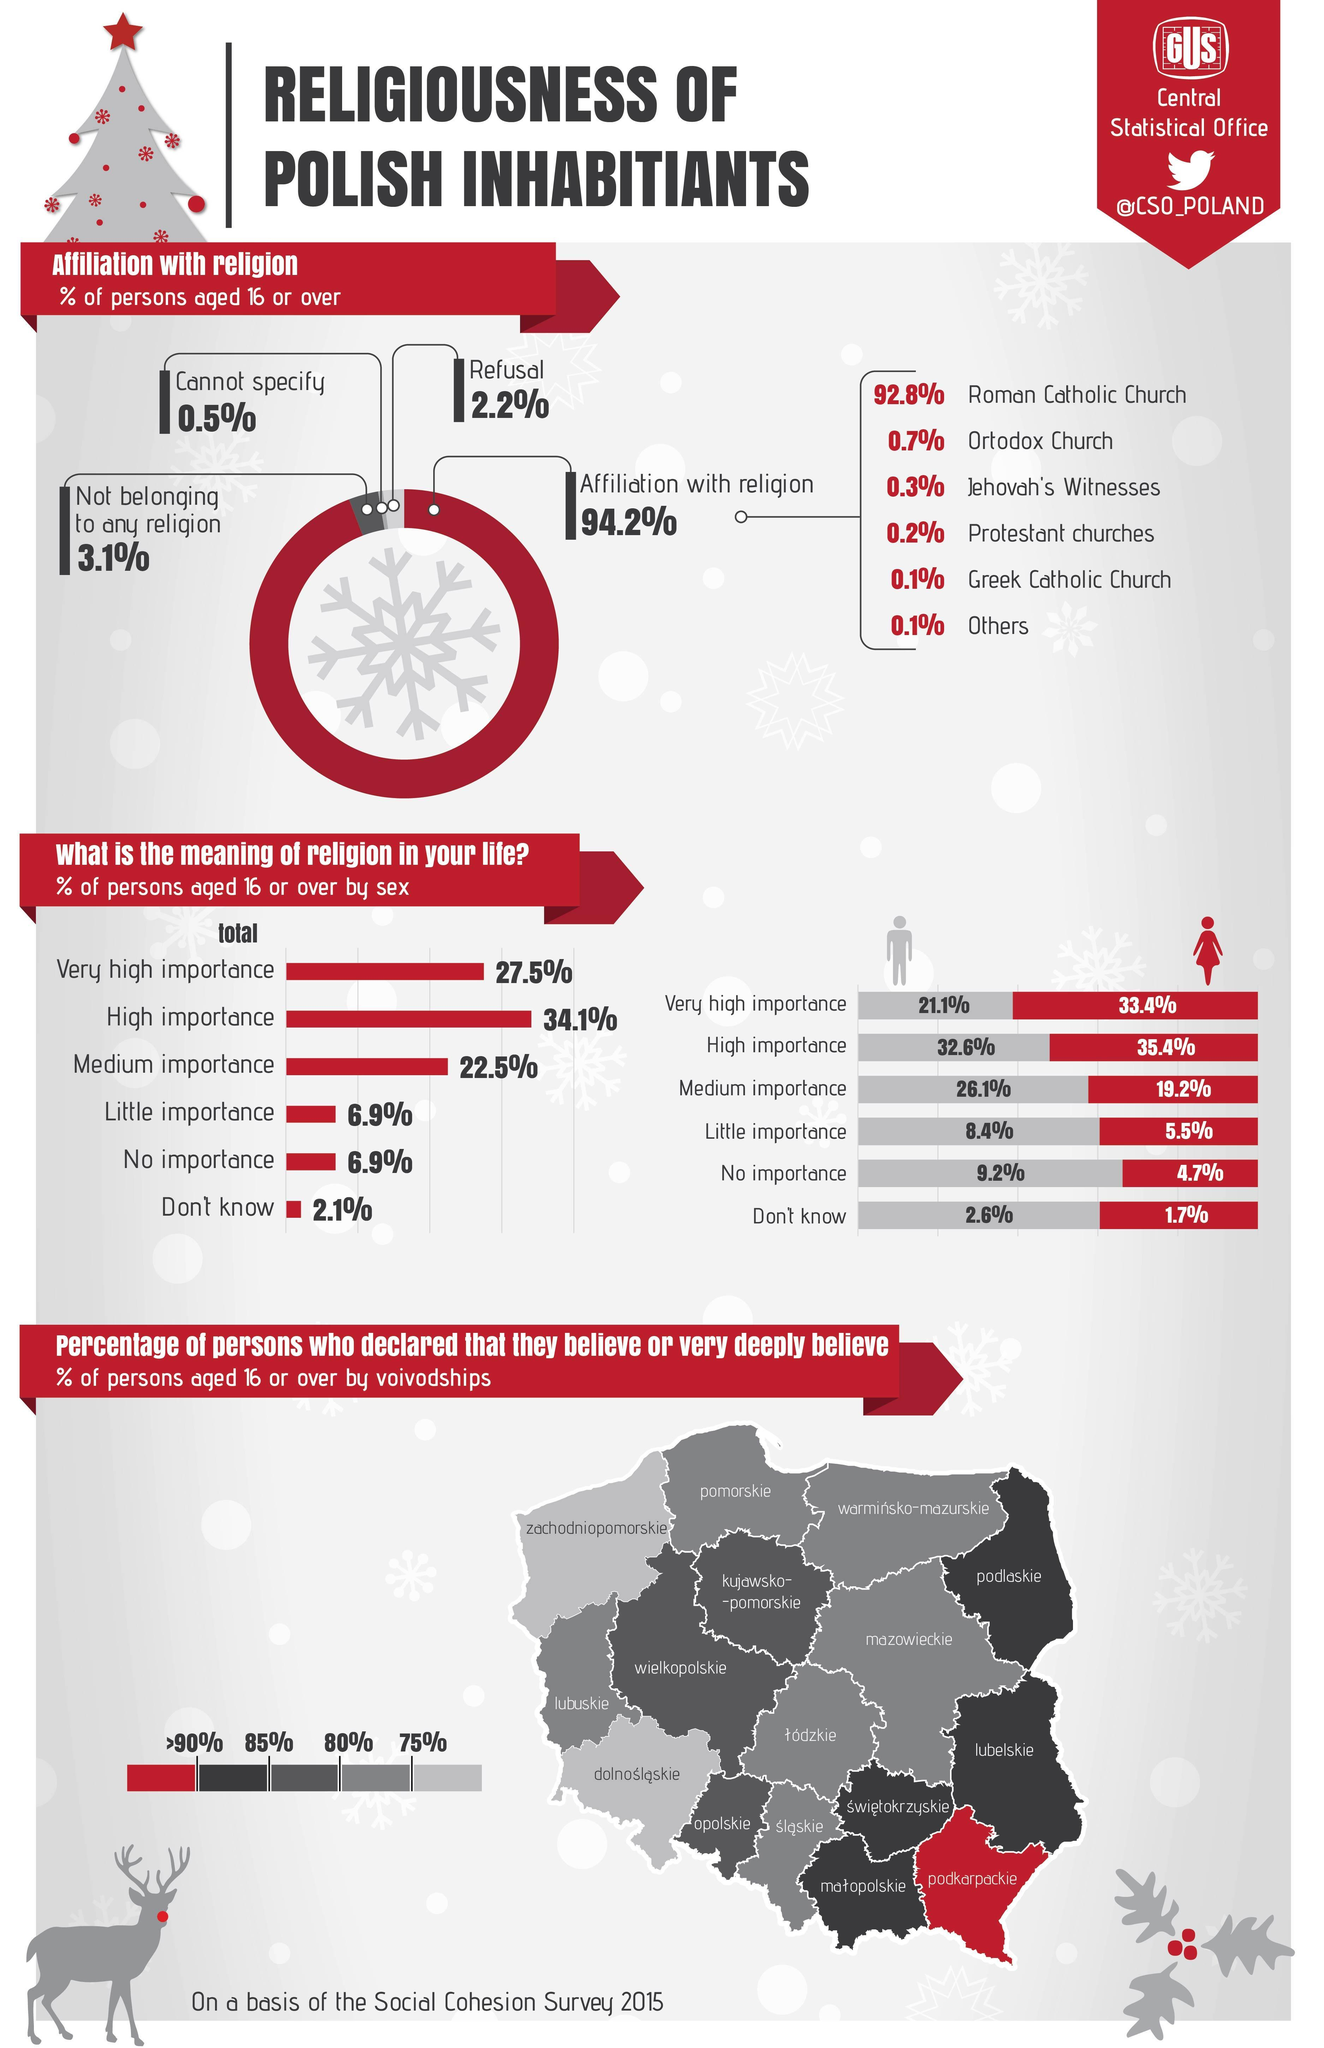What percentage of males aged 16 or over give very high importance to religion in Poland according to 2015 survey?
Answer the question with a short phrase. 21.1% What percentage of females aged 16 or over give no importance to religion in Poland according to 2015 survey? 4.7% What percentage of persons aged 16 or over do not belong to any religion in Poland according to 2015 survey? 3.1% In which church affiliation, majority of the polish people belongs to? Roman Catholic Church What percentage of females aged 16 or over give high importance to religion in Poland according to 2015 survey? 35.4% What percentage of persons aged 16 or over are affiliated to Roman Catholic religion in Poland according to 2015 survey? 92.8% What percentage of males aged 16 or over give little importance to religion in Poland according to 2015 survey? 8.4% What percentage of males aged 16 or over don't know about religion in Poland according to 2015 survey? 2.6% What percentage of persons aged 16 or over are affiliated to orthodox religion in Poland according to 2015 survey? 0.7% Which is the second famous religious church in Poland? Ortodox Church 